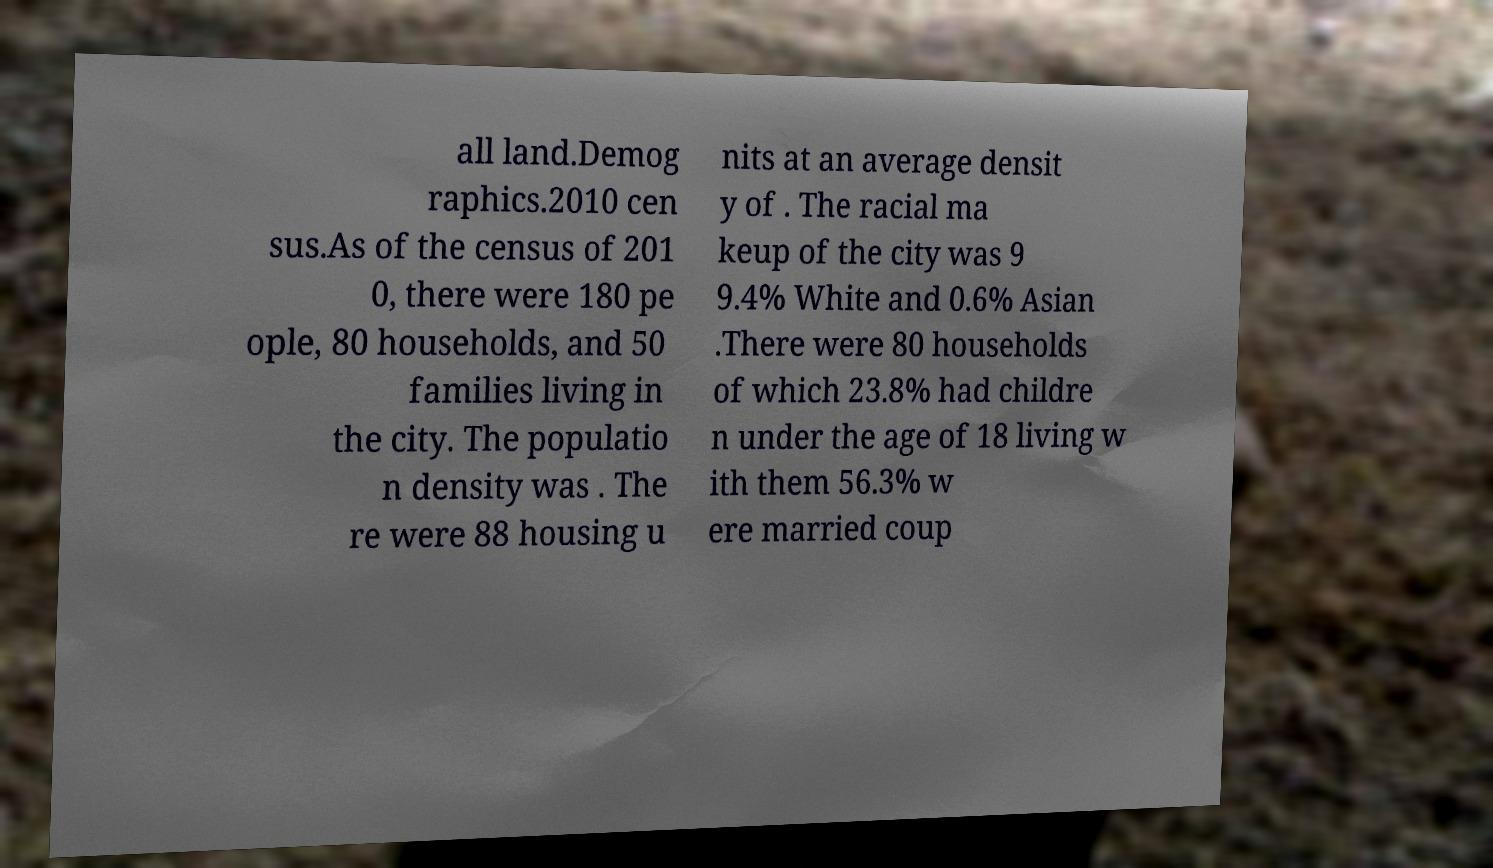There's text embedded in this image that I need extracted. Can you transcribe it verbatim? all land.Demog raphics.2010 cen sus.As of the census of 201 0, there were 180 pe ople, 80 households, and 50 families living in the city. The populatio n density was . The re were 88 housing u nits at an average densit y of . The racial ma keup of the city was 9 9.4% White and 0.6% Asian .There were 80 households of which 23.8% had childre n under the age of 18 living w ith them 56.3% w ere married coup 